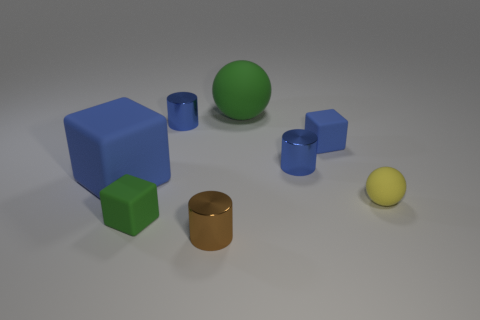Subtract all tiny blue cubes. How many cubes are left? 2 Subtract all blue blocks. How many were subtracted if there are1blue blocks left? 1 Subtract all brown cylinders. How many cylinders are left? 2 Subtract 1 blocks. How many blocks are left? 2 Subtract all cyan balls. Subtract all blue cubes. How many balls are left? 2 Subtract all gray spheres. How many blue blocks are left? 2 Subtract all green rubber objects. Subtract all yellow objects. How many objects are left? 5 Add 3 large blue things. How many large blue things are left? 4 Add 6 small matte cubes. How many small matte cubes exist? 8 Add 2 gray balls. How many objects exist? 10 